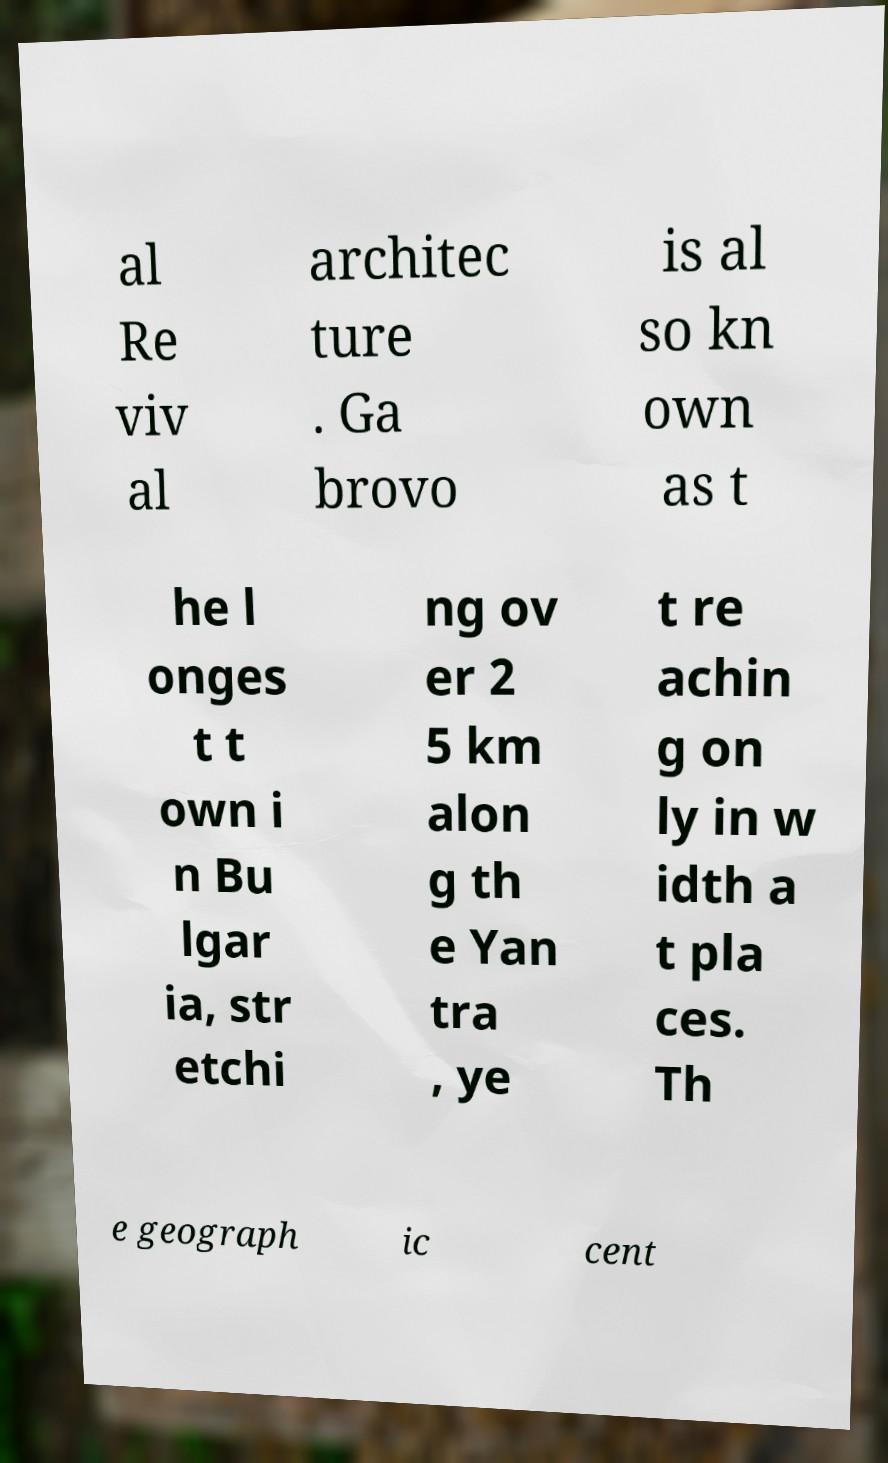Could you assist in decoding the text presented in this image and type it out clearly? al Re viv al architec ture . Ga brovo is al so kn own as t he l onges t t own i n Bu lgar ia, str etchi ng ov er 2 5 km alon g th e Yan tra , ye t re achin g on ly in w idth a t pla ces. Th e geograph ic cent 